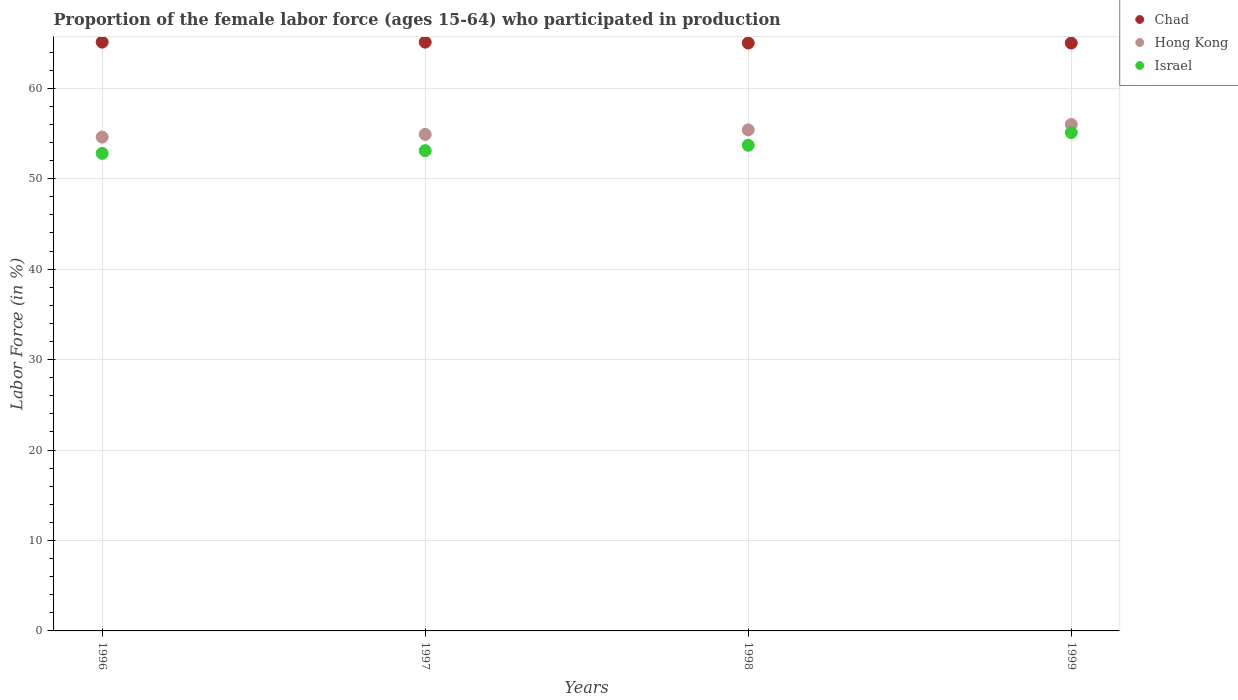Is the number of dotlines equal to the number of legend labels?
Make the answer very short. Yes. What is the proportion of the female labor force who participated in production in Chad in 1996?
Offer a terse response. 65.1. Across all years, what is the maximum proportion of the female labor force who participated in production in Israel?
Your answer should be compact. 55.1. What is the total proportion of the female labor force who participated in production in Chad in the graph?
Your answer should be compact. 260.2. What is the difference between the proportion of the female labor force who participated in production in Israel in 1998 and that in 1999?
Make the answer very short. -1.4. What is the difference between the proportion of the female labor force who participated in production in Israel in 1997 and the proportion of the female labor force who participated in production in Chad in 1996?
Ensure brevity in your answer.  -12. What is the average proportion of the female labor force who participated in production in Hong Kong per year?
Offer a terse response. 55.23. In the year 1997, what is the difference between the proportion of the female labor force who participated in production in Chad and proportion of the female labor force who participated in production in Hong Kong?
Provide a short and direct response. 10.2. In how many years, is the proportion of the female labor force who participated in production in Chad greater than 26 %?
Your answer should be compact. 4. What is the ratio of the proportion of the female labor force who participated in production in Hong Kong in 1997 to that in 1999?
Your answer should be very brief. 0.98. Is the proportion of the female labor force who participated in production in Israel in 1996 less than that in 1997?
Your answer should be compact. Yes. Is the difference between the proportion of the female labor force who participated in production in Chad in 1997 and 1998 greater than the difference between the proportion of the female labor force who participated in production in Hong Kong in 1997 and 1998?
Offer a very short reply. Yes. What is the difference between the highest and the second highest proportion of the female labor force who participated in production in Hong Kong?
Offer a terse response. 0.6. What is the difference between the highest and the lowest proportion of the female labor force who participated in production in Israel?
Offer a terse response. 2.3. In how many years, is the proportion of the female labor force who participated in production in Israel greater than the average proportion of the female labor force who participated in production in Israel taken over all years?
Provide a short and direct response. 2. Is it the case that in every year, the sum of the proportion of the female labor force who participated in production in Chad and proportion of the female labor force who participated in production in Israel  is greater than the proportion of the female labor force who participated in production in Hong Kong?
Offer a very short reply. Yes. Is the proportion of the female labor force who participated in production in Hong Kong strictly greater than the proportion of the female labor force who participated in production in Israel over the years?
Give a very brief answer. Yes. How many years are there in the graph?
Give a very brief answer. 4. What is the difference between two consecutive major ticks on the Y-axis?
Give a very brief answer. 10. Does the graph contain any zero values?
Offer a terse response. No. Where does the legend appear in the graph?
Your response must be concise. Top right. How are the legend labels stacked?
Give a very brief answer. Vertical. What is the title of the graph?
Ensure brevity in your answer.  Proportion of the female labor force (ages 15-64) who participated in production. Does "Central African Republic" appear as one of the legend labels in the graph?
Provide a short and direct response. No. What is the label or title of the Y-axis?
Provide a short and direct response. Labor Force (in %). What is the Labor Force (in %) in Chad in 1996?
Keep it short and to the point. 65.1. What is the Labor Force (in %) of Hong Kong in 1996?
Your response must be concise. 54.6. What is the Labor Force (in %) of Israel in 1996?
Offer a terse response. 52.8. What is the Labor Force (in %) in Chad in 1997?
Offer a very short reply. 65.1. What is the Labor Force (in %) in Hong Kong in 1997?
Provide a succinct answer. 54.9. What is the Labor Force (in %) of Israel in 1997?
Ensure brevity in your answer.  53.1. What is the Labor Force (in %) of Hong Kong in 1998?
Your response must be concise. 55.4. What is the Labor Force (in %) of Israel in 1998?
Provide a succinct answer. 53.7. What is the Labor Force (in %) of Hong Kong in 1999?
Ensure brevity in your answer.  56. What is the Labor Force (in %) of Israel in 1999?
Give a very brief answer. 55.1. Across all years, what is the maximum Labor Force (in %) in Chad?
Give a very brief answer. 65.1. Across all years, what is the maximum Labor Force (in %) in Hong Kong?
Provide a short and direct response. 56. Across all years, what is the maximum Labor Force (in %) in Israel?
Make the answer very short. 55.1. Across all years, what is the minimum Labor Force (in %) in Hong Kong?
Your answer should be compact. 54.6. Across all years, what is the minimum Labor Force (in %) in Israel?
Keep it short and to the point. 52.8. What is the total Labor Force (in %) in Chad in the graph?
Offer a terse response. 260.2. What is the total Labor Force (in %) of Hong Kong in the graph?
Your answer should be very brief. 220.9. What is the total Labor Force (in %) of Israel in the graph?
Provide a short and direct response. 214.7. What is the difference between the Labor Force (in %) of Chad in 1996 and that in 1997?
Your answer should be compact. 0. What is the difference between the Labor Force (in %) in Hong Kong in 1996 and that in 1997?
Your answer should be compact. -0.3. What is the difference between the Labor Force (in %) of Hong Kong in 1996 and that in 1998?
Your answer should be very brief. -0.8. What is the difference between the Labor Force (in %) of Israel in 1996 and that in 1998?
Ensure brevity in your answer.  -0.9. What is the difference between the Labor Force (in %) of Hong Kong in 1996 and that in 1999?
Your answer should be very brief. -1.4. What is the difference between the Labor Force (in %) in Israel in 1996 and that in 1999?
Offer a very short reply. -2.3. What is the difference between the Labor Force (in %) of Chad in 1997 and that in 1998?
Ensure brevity in your answer.  0.1. What is the difference between the Labor Force (in %) of Hong Kong in 1997 and that in 1999?
Offer a terse response. -1.1. What is the difference between the Labor Force (in %) of Israel in 1997 and that in 1999?
Make the answer very short. -2. What is the difference between the Labor Force (in %) in Chad in 1998 and that in 1999?
Ensure brevity in your answer.  0. What is the difference between the Labor Force (in %) in Hong Kong in 1998 and that in 1999?
Give a very brief answer. -0.6. What is the difference between the Labor Force (in %) in Israel in 1998 and that in 1999?
Your answer should be very brief. -1.4. What is the difference between the Labor Force (in %) of Chad in 1996 and the Labor Force (in %) of Israel in 1997?
Keep it short and to the point. 12. What is the difference between the Labor Force (in %) of Hong Kong in 1996 and the Labor Force (in %) of Israel in 1997?
Keep it short and to the point. 1.5. What is the difference between the Labor Force (in %) of Chad in 1996 and the Labor Force (in %) of Hong Kong in 1998?
Provide a short and direct response. 9.7. What is the difference between the Labor Force (in %) of Chad in 1996 and the Labor Force (in %) of Israel in 1999?
Offer a terse response. 10. What is the difference between the Labor Force (in %) in Chad in 1997 and the Labor Force (in %) in Israel in 1998?
Your answer should be very brief. 11.4. What is the difference between the Labor Force (in %) in Chad in 1997 and the Labor Force (in %) in Israel in 1999?
Ensure brevity in your answer.  10. What is the difference between the Labor Force (in %) in Chad in 1998 and the Labor Force (in %) in Hong Kong in 1999?
Your answer should be compact. 9. What is the difference between the Labor Force (in %) of Hong Kong in 1998 and the Labor Force (in %) of Israel in 1999?
Keep it short and to the point. 0.3. What is the average Labor Force (in %) in Chad per year?
Your answer should be very brief. 65.05. What is the average Labor Force (in %) of Hong Kong per year?
Offer a very short reply. 55.23. What is the average Labor Force (in %) in Israel per year?
Make the answer very short. 53.67. In the year 1996, what is the difference between the Labor Force (in %) of Chad and Labor Force (in %) of Israel?
Your response must be concise. 12.3. In the year 1996, what is the difference between the Labor Force (in %) in Hong Kong and Labor Force (in %) in Israel?
Make the answer very short. 1.8. In the year 1997, what is the difference between the Labor Force (in %) in Chad and Labor Force (in %) in Israel?
Offer a terse response. 12. In the year 1997, what is the difference between the Labor Force (in %) of Hong Kong and Labor Force (in %) of Israel?
Offer a very short reply. 1.8. In the year 1998, what is the difference between the Labor Force (in %) of Chad and Labor Force (in %) of Hong Kong?
Your answer should be compact. 9.6. What is the ratio of the Labor Force (in %) of Chad in 1996 to that in 1997?
Offer a very short reply. 1. What is the ratio of the Labor Force (in %) of Hong Kong in 1996 to that in 1997?
Offer a terse response. 0.99. What is the ratio of the Labor Force (in %) in Israel in 1996 to that in 1997?
Provide a short and direct response. 0.99. What is the ratio of the Labor Force (in %) of Hong Kong in 1996 to that in 1998?
Keep it short and to the point. 0.99. What is the ratio of the Labor Force (in %) in Israel in 1996 to that in 1998?
Make the answer very short. 0.98. What is the ratio of the Labor Force (in %) in Hong Kong in 1996 to that in 1999?
Your answer should be compact. 0.97. What is the ratio of the Labor Force (in %) of Israel in 1996 to that in 1999?
Your response must be concise. 0.96. What is the ratio of the Labor Force (in %) of Israel in 1997 to that in 1998?
Give a very brief answer. 0.99. What is the ratio of the Labor Force (in %) of Chad in 1997 to that in 1999?
Keep it short and to the point. 1. What is the ratio of the Labor Force (in %) in Hong Kong in 1997 to that in 1999?
Offer a very short reply. 0.98. What is the ratio of the Labor Force (in %) of Israel in 1997 to that in 1999?
Provide a succinct answer. 0.96. What is the ratio of the Labor Force (in %) of Hong Kong in 1998 to that in 1999?
Offer a very short reply. 0.99. What is the ratio of the Labor Force (in %) of Israel in 1998 to that in 1999?
Give a very brief answer. 0.97. What is the difference between the highest and the second highest Labor Force (in %) of Hong Kong?
Your answer should be compact. 0.6. 